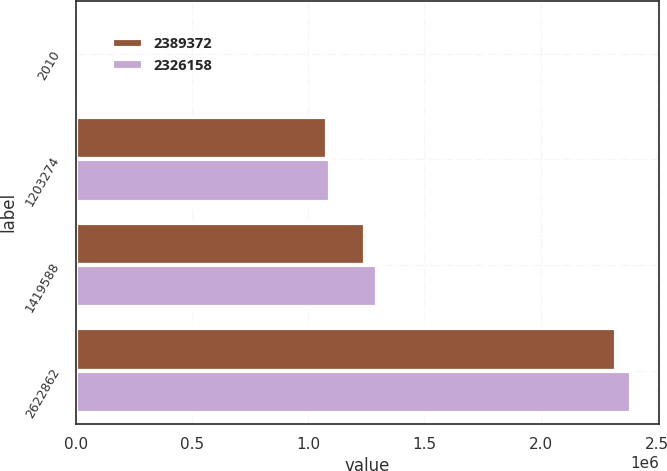Convert chart to OTSL. <chart><loc_0><loc_0><loc_500><loc_500><stacked_bar_chart><ecel><fcel>2010<fcel>1203274<fcel>1419588<fcel>2622862<nl><fcel>2.38937e+06<fcel>2009<fcel>1.08149e+06<fcel>1.24467e+06<fcel>2.32616e+06<nl><fcel>2.32616e+06<fcel>2008<fcel>1.09254e+06<fcel>1.29683e+06<fcel>2.38937e+06<nl></chart> 